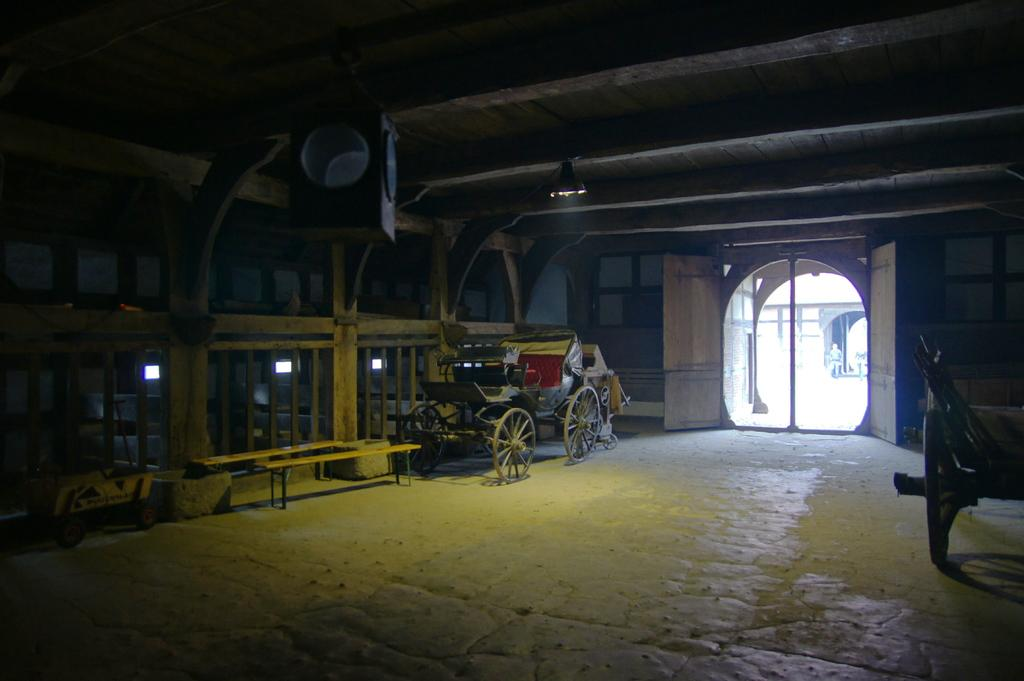What is located in the middle of the image? There is a cart in the middle of the image. Where is the entrance with a glass door in the image? The entrance with a glass door is on the right side of the image. What can be found on the left side of the image? There are benches on the left side of the image. What type of breakfast is being served at the church in the image? There is no church or breakfast present in the image; it features a cart, an entrance with a glass door, and benches. Where is the playground located in the image? There is no playground present in the image. 